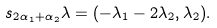<formula> <loc_0><loc_0><loc_500><loc_500>s _ { 2 \alpha _ { 1 } + \alpha _ { 2 } } \lambda = ( - \lambda _ { 1 } - 2 \lambda _ { 2 } , \lambda _ { 2 } ) .</formula> 